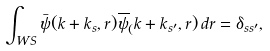<formula> <loc_0><loc_0><loc_500><loc_500>\int _ { W S } \bar { \psi } ( { k } + { k } _ { s } , { r } ) \overline { \psi } _ { ( } { k } + { k } _ { s ^ { \prime } } , { r } ) \, d { r } = \delta _ { s s ^ { \prime } } ,</formula> 